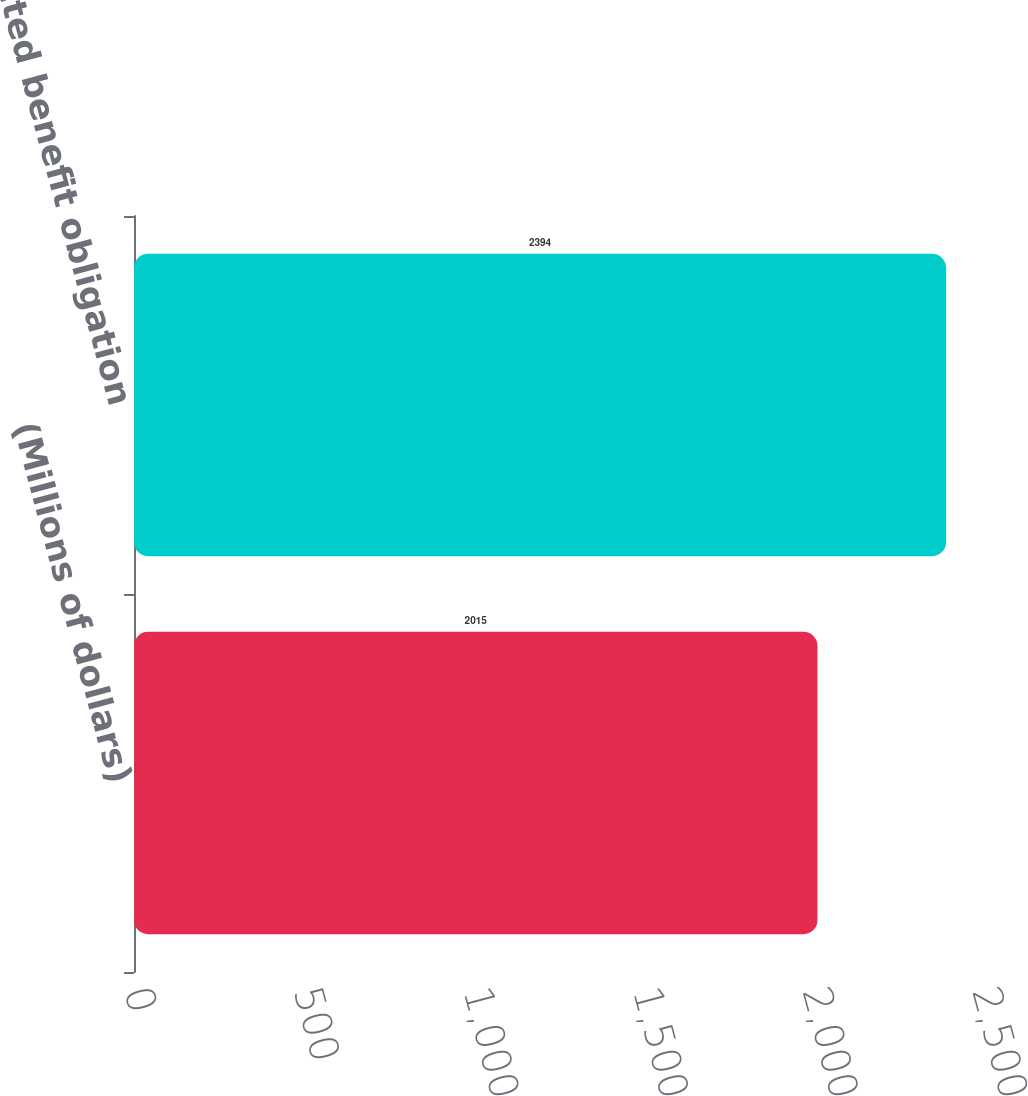<chart> <loc_0><loc_0><loc_500><loc_500><bar_chart><fcel>(Millions of dollars)<fcel>Projected benefit obligation<nl><fcel>2015<fcel>2394<nl></chart> 